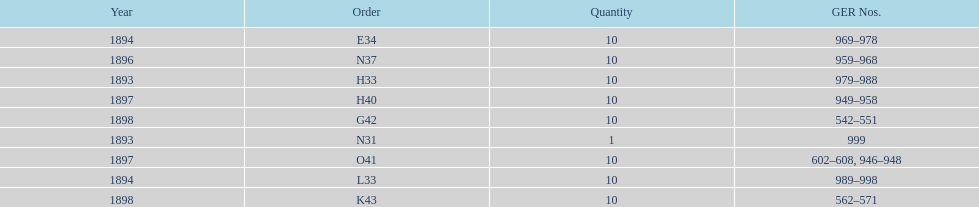What is the order of the last year listed? K43. 